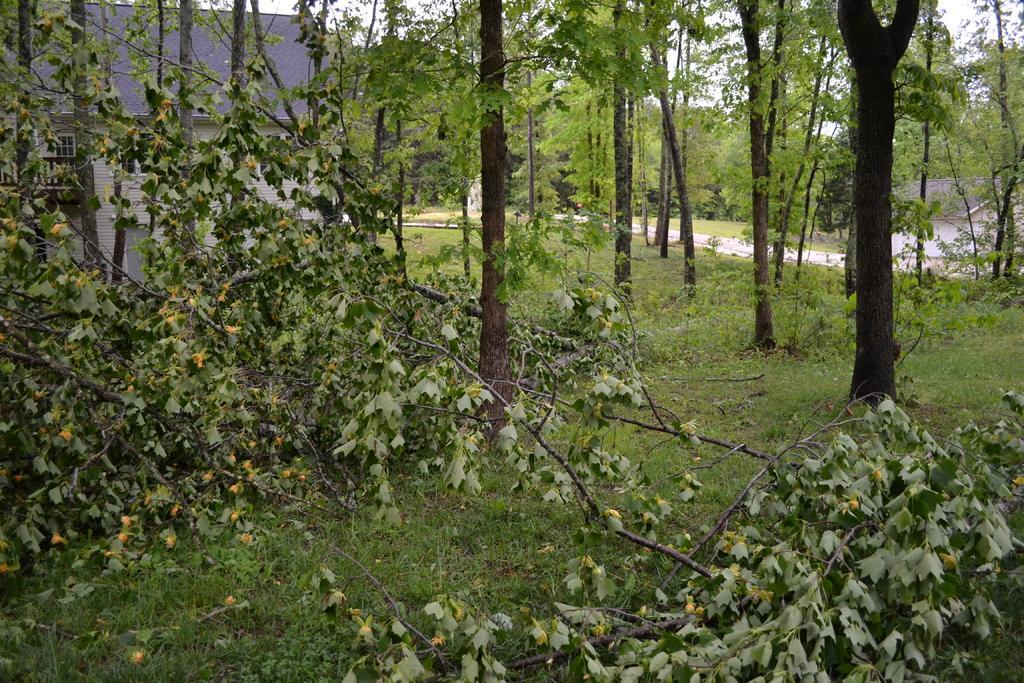Please provide a concise description of this image. This image consists of many trees. At the bottom, there is green grass. To the left, there is a small house. 